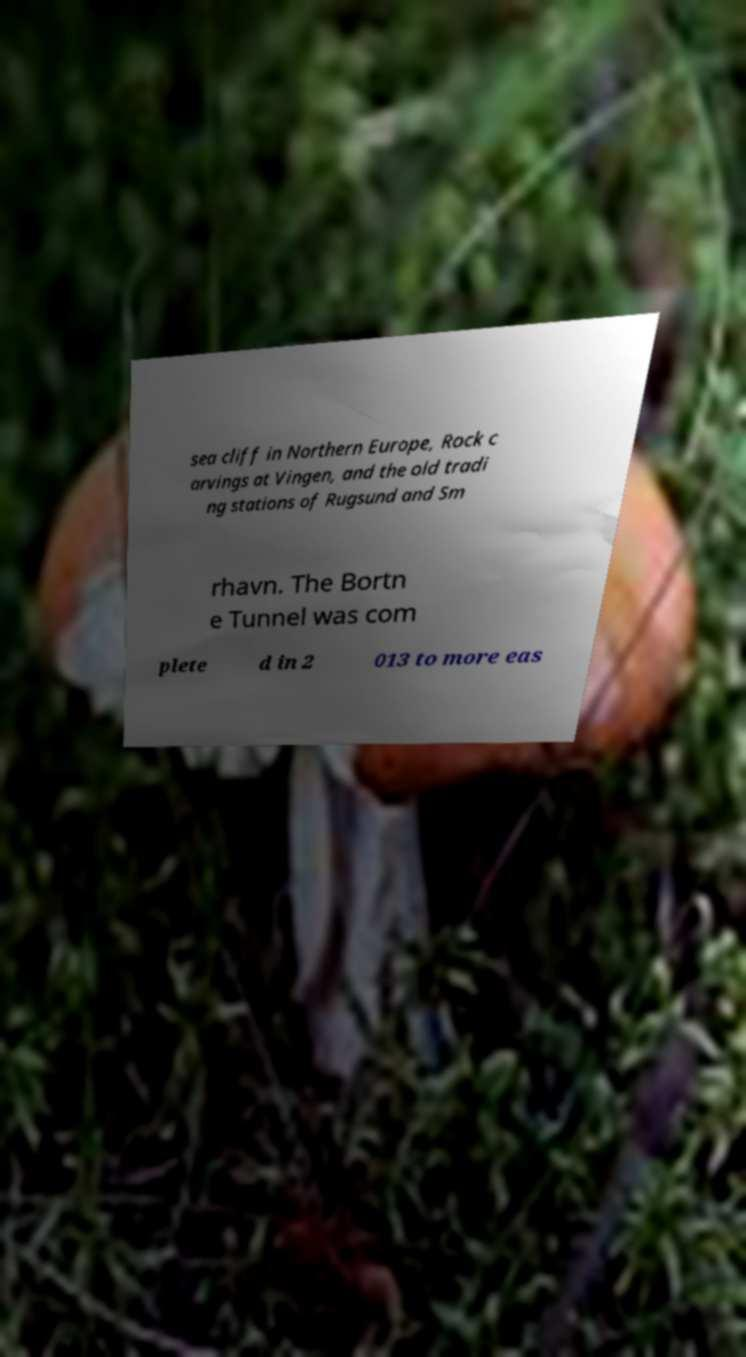What messages or text are displayed in this image? I need them in a readable, typed format. sea cliff in Northern Europe, Rock c arvings at Vingen, and the old tradi ng stations of Rugsund and Sm rhavn. The Bortn e Tunnel was com plete d in 2 013 to more eas 